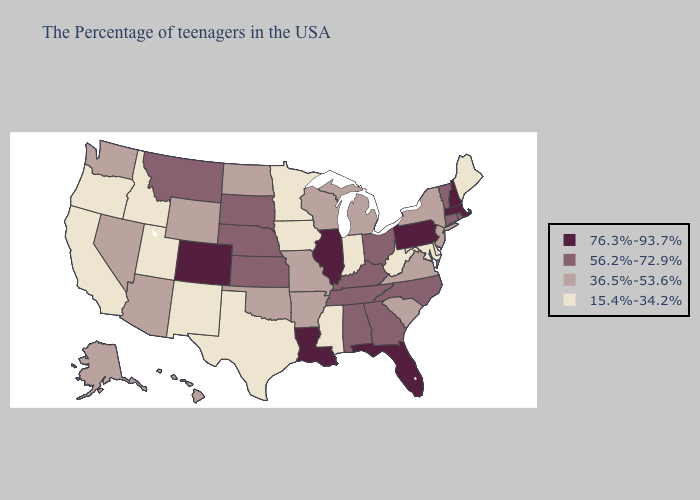What is the value of Florida?
Be succinct. 76.3%-93.7%. Which states hav the highest value in the MidWest?
Give a very brief answer. Illinois. What is the lowest value in states that border Missouri?
Answer briefly. 15.4%-34.2%. Does Wisconsin have the same value as Vermont?
Be succinct. No. Name the states that have a value in the range 56.2%-72.9%?
Answer briefly. Rhode Island, Vermont, Connecticut, North Carolina, Ohio, Georgia, Kentucky, Alabama, Tennessee, Kansas, Nebraska, South Dakota, Montana. Does the first symbol in the legend represent the smallest category?
Concise answer only. No. Is the legend a continuous bar?
Short answer required. No. What is the lowest value in states that border Indiana?
Keep it brief. 36.5%-53.6%. What is the value of Hawaii?
Give a very brief answer. 36.5%-53.6%. Does New Hampshire have the highest value in the USA?
Short answer required. Yes. Name the states that have a value in the range 15.4%-34.2%?
Write a very short answer. Maine, Delaware, Maryland, West Virginia, Indiana, Mississippi, Minnesota, Iowa, Texas, New Mexico, Utah, Idaho, California, Oregon. What is the value of Hawaii?
Short answer required. 36.5%-53.6%. Does the first symbol in the legend represent the smallest category?
Give a very brief answer. No. Which states have the lowest value in the West?
Write a very short answer. New Mexico, Utah, Idaho, California, Oregon. 